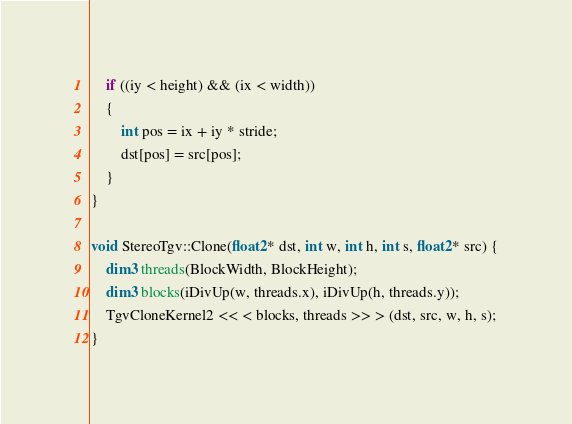<code> <loc_0><loc_0><loc_500><loc_500><_Cuda_>
	if ((iy < height) && (ix < width))
	{
		int pos = ix + iy * stride;
		dst[pos] = src[pos];
	}
}

void StereoTgv::Clone(float2* dst, int w, int h, int s, float2* src) {
	dim3 threads(BlockWidth, BlockHeight);
	dim3 blocks(iDivUp(w, threads.x), iDivUp(h, threads.y));
	TgvCloneKernel2 << < blocks, threads >> > (dst, src, w, h, s);
}</code> 